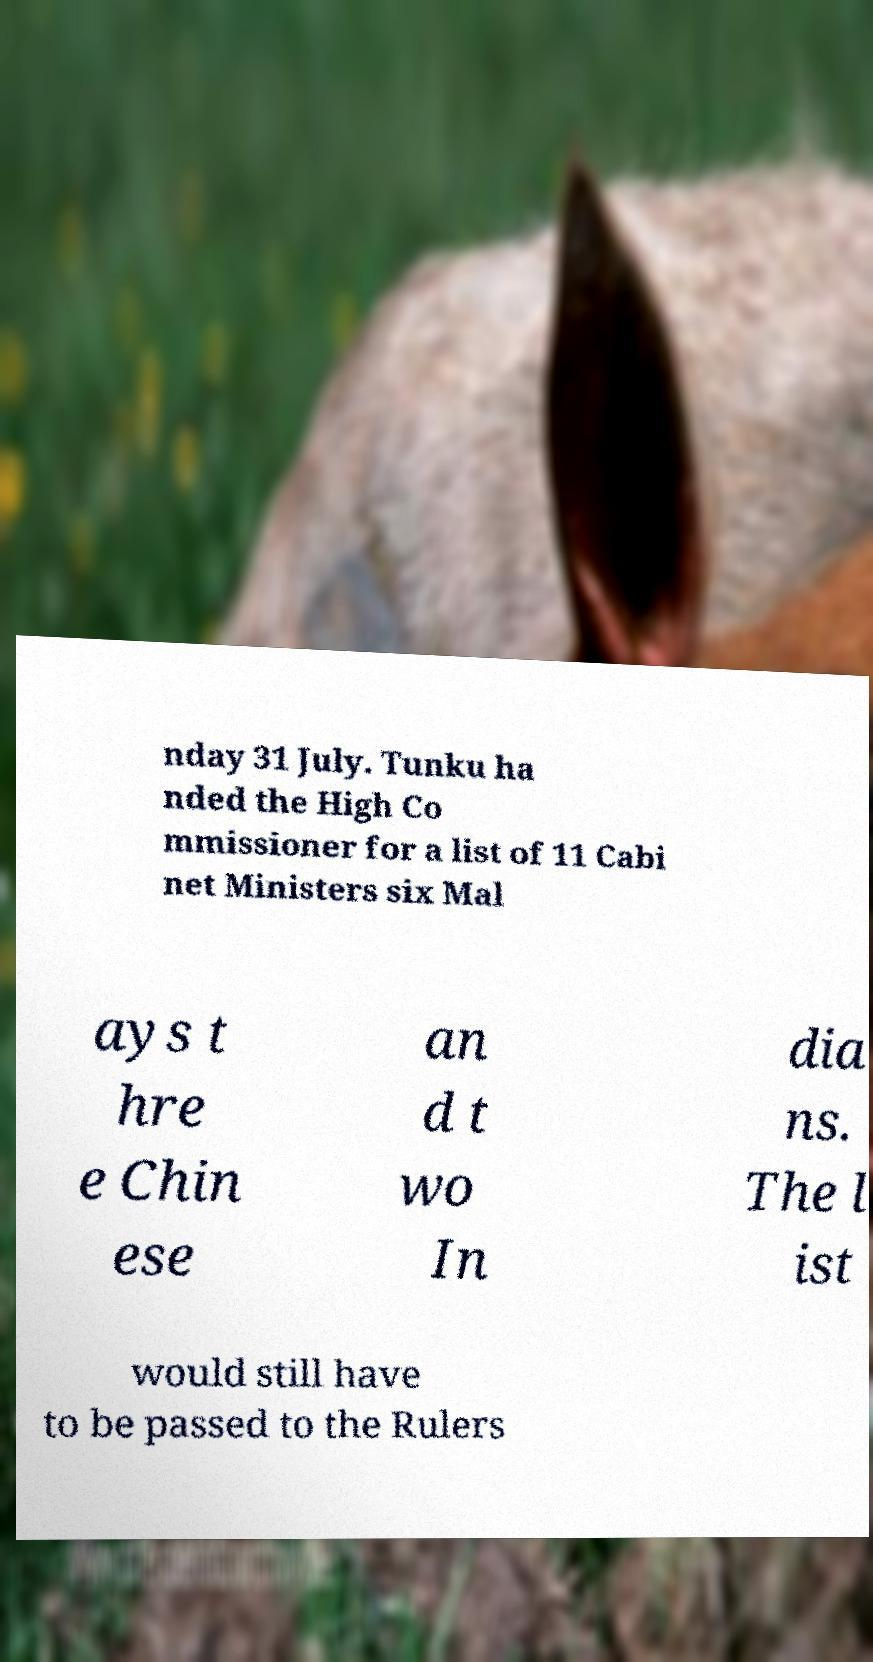Please read and relay the text visible in this image. What does it say? nday 31 July. Tunku ha nded the High Co mmissioner for a list of 11 Cabi net Ministers six Mal ays t hre e Chin ese an d t wo In dia ns. The l ist would still have to be passed to the Rulers 